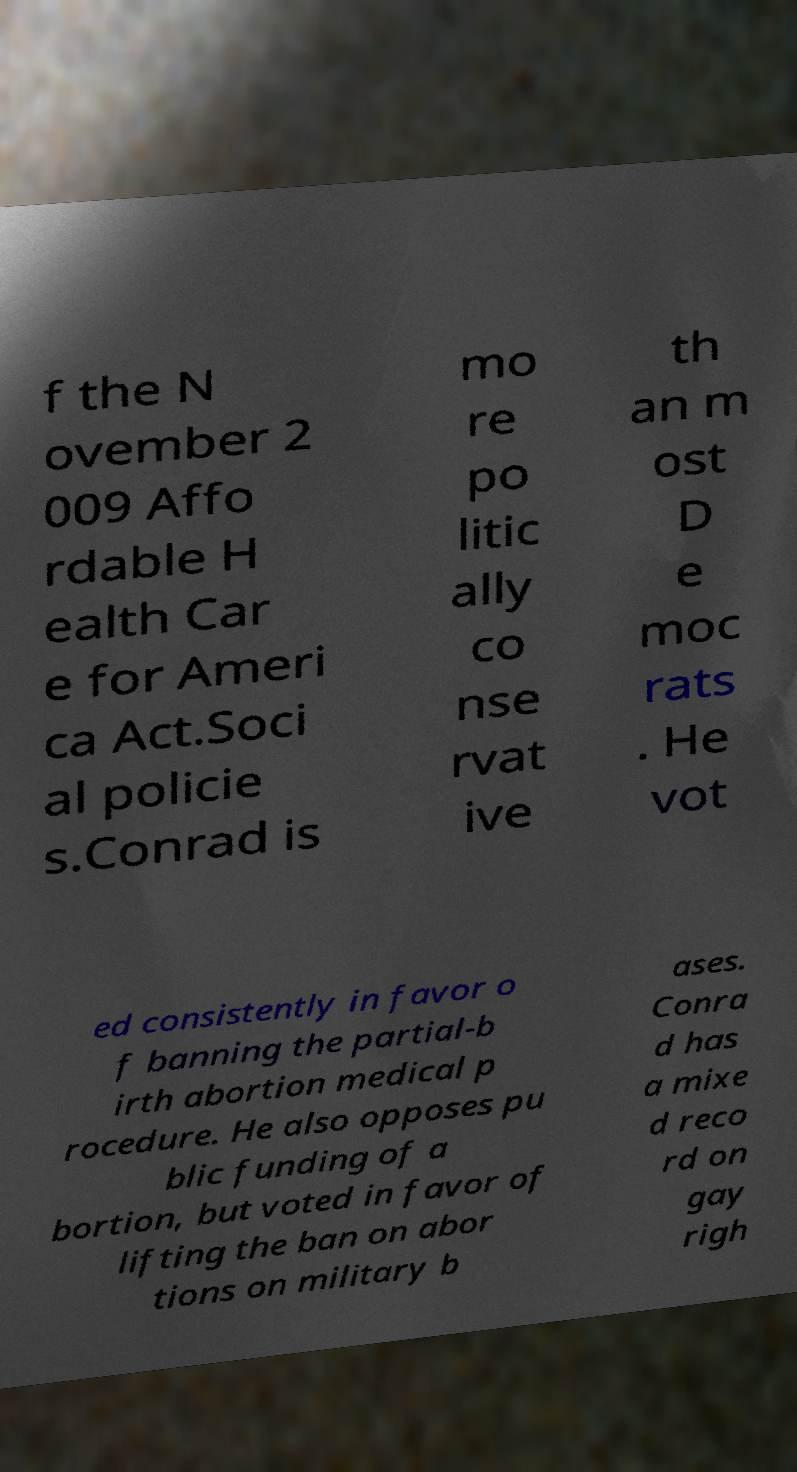Could you extract and type out the text from this image? f the N ovember 2 009 Affo rdable H ealth Car e for Ameri ca Act.Soci al policie s.Conrad is mo re po litic ally co nse rvat ive th an m ost D e moc rats . He vot ed consistently in favor o f banning the partial-b irth abortion medical p rocedure. He also opposes pu blic funding of a bortion, but voted in favor of lifting the ban on abor tions on military b ases. Conra d has a mixe d reco rd on gay righ 